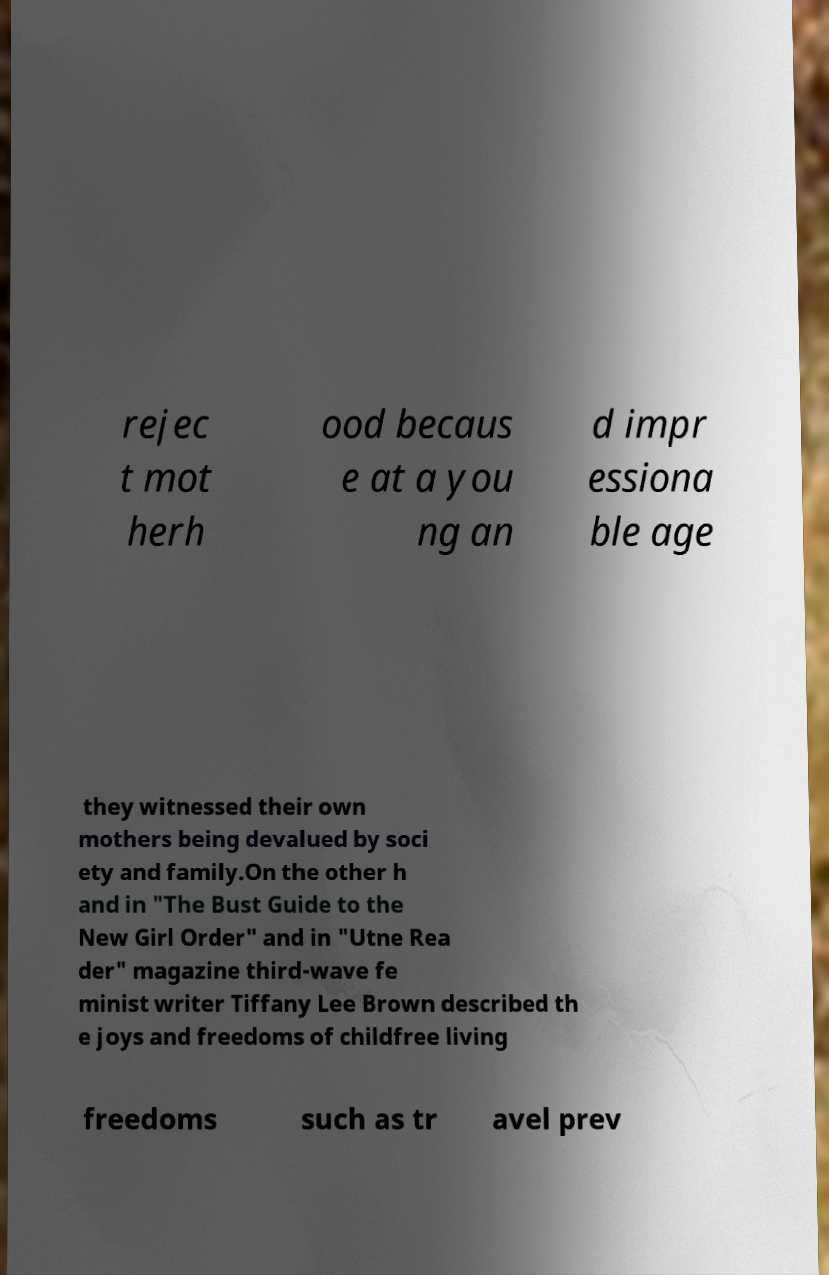For documentation purposes, I need the text within this image transcribed. Could you provide that? rejec t mot herh ood becaus e at a you ng an d impr essiona ble age they witnessed their own mothers being devalued by soci ety and family.On the other h and in "The Bust Guide to the New Girl Order" and in "Utne Rea der" magazine third-wave fe minist writer Tiffany Lee Brown described th e joys and freedoms of childfree living freedoms such as tr avel prev 